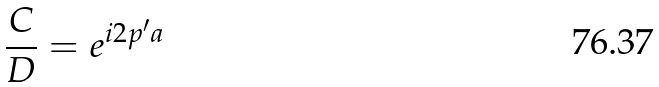<formula> <loc_0><loc_0><loc_500><loc_500>\frac { C } { D } = e ^ { i 2 p ^ { \prime } a }</formula> 